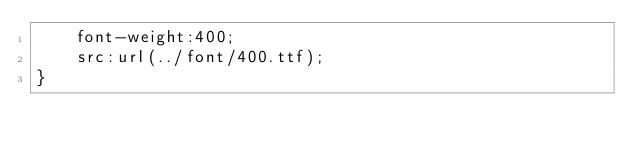<code> <loc_0><loc_0><loc_500><loc_500><_CSS_>	font-weight:400;
	src:url(../font/400.ttf);
}</code> 